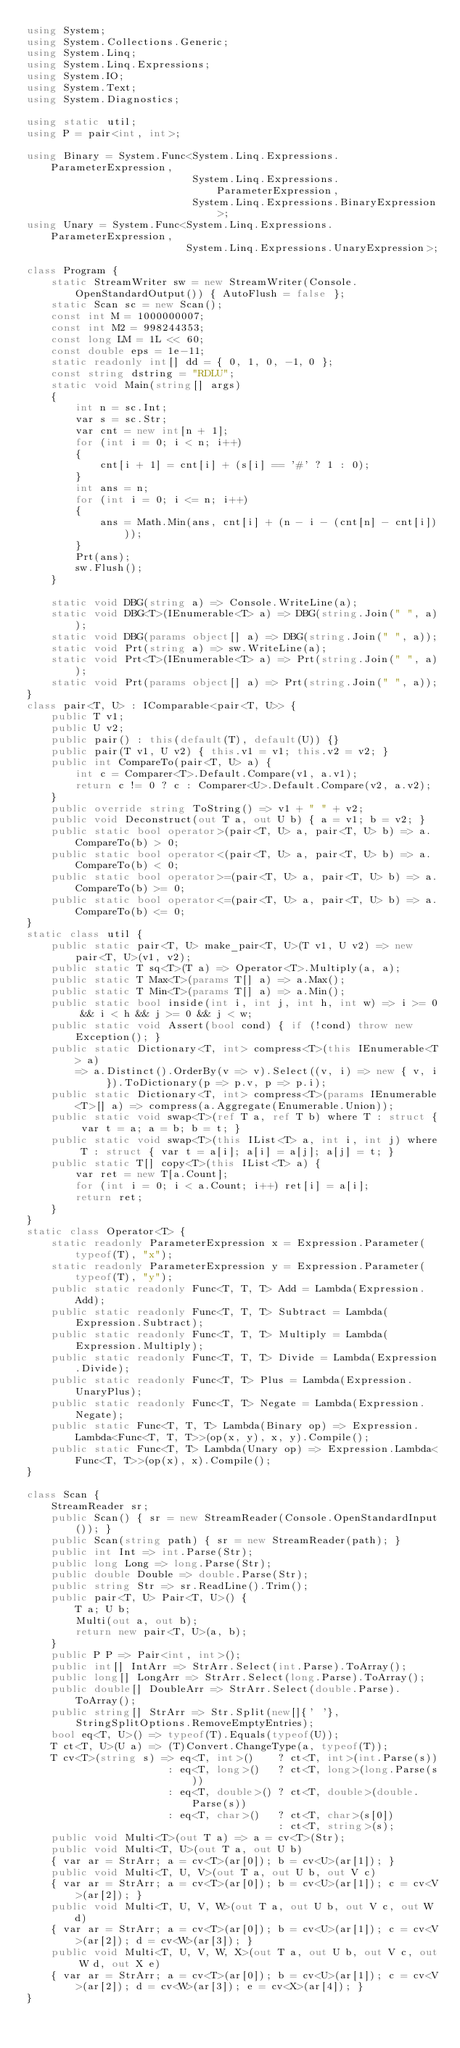<code> <loc_0><loc_0><loc_500><loc_500><_C#_>using System;
using System.Collections.Generic;
using System.Linq;
using System.Linq.Expressions;
using System.IO;
using System.Text;
using System.Diagnostics;

using static util;
using P = pair<int, int>;

using Binary = System.Func<System.Linq.Expressions.ParameterExpression,
                           System.Linq.Expressions.ParameterExpression,
                           System.Linq.Expressions.BinaryExpression>;
using Unary = System.Func<System.Linq.Expressions.ParameterExpression,
                          System.Linq.Expressions.UnaryExpression>;

class Program {
    static StreamWriter sw = new StreamWriter(Console.OpenStandardOutput()) { AutoFlush = false };
    static Scan sc = new Scan();
    const int M = 1000000007;
    const int M2 = 998244353;
    const long LM = 1L << 60;
    const double eps = 1e-11;
    static readonly int[] dd = { 0, 1, 0, -1, 0 };
    const string dstring = "RDLU";
    static void Main(string[] args)
    {
        int n = sc.Int;
        var s = sc.Str;
        var cnt = new int[n + 1];
        for (int i = 0; i < n; i++)
        {
            cnt[i + 1] = cnt[i] + (s[i] == '#' ? 1 : 0);
        }
        int ans = n;
        for (int i = 0; i <= n; i++)
        {
            ans = Math.Min(ans, cnt[i] + (n - i - (cnt[n] - cnt[i])));
        }
        Prt(ans);
        sw.Flush();
    }

    static void DBG(string a) => Console.WriteLine(a);
    static void DBG<T>(IEnumerable<T> a) => DBG(string.Join(" ", a));
    static void DBG(params object[] a) => DBG(string.Join(" ", a));
    static void Prt(string a) => sw.WriteLine(a);
    static void Prt<T>(IEnumerable<T> a) => Prt(string.Join(" ", a));
    static void Prt(params object[] a) => Prt(string.Join(" ", a));
}
class pair<T, U> : IComparable<pair<T, U>> {
    public T v1;
    public U v2;
    public pair() : this(default(T), default(U)) {}
    public pair(T v1, U v2) { this.v1 = v1; this.v2 = v2; }
    public int CompareTo(pair<T, U> a) {
        int c = Comparer<T>.Default.Compare(v1, a.v1);
        return c != 0 ? c : Comparer<U>.Default.Compare(v2, a.v2);
    }
    public override string ToString() => v1 + " " + v2;
    public void Deconstruct(out T a, out U b) { a = v1; b = v2; }
    public static bool operator>(pair<T, U> a, pair<T, U> b) => a.CompareTo(b) > 0;
    public static bool operator<(pair<T, U> a, pair<T, U> b) => a.CompareTo(b) < 0;
    public static bool operator>=(pair<T, U> a, pair<T, U> b) => a.CompareTo(b) >= 0;
    public static bool operator<=(pair<T, U> a, pair<T, U> b) => a.CompareTo(b) <= 0;
}
static class util {
    public static pair<T, U> make_pair<T, U>(T v1, U v2) => new pair<T, U>(v1, v2);
    public static T sq<T>(T a) => Operator<T>.Multiply(a, a);
    public static T Max<T>(params T[] a) => a.Max();
    public static T Min<T>(params T[] a) => a.Min();
    public static bool inside(int i, int j, int h, int w) => i >= 0 && i < h && j >= 0 && j < w;
    public static void Assert(bool cond) { if (!cond) throw new Exception(); }
    public static Dictionary<T, int> compress<T>(this IEnumerable<T> a)
        => a.Distinct().OrderBy(v => v).Select((v, i) => new { v, i }).ToDictionary(p => p.v, p => p.i);
    public static Dictionary<T, int> compress<T>(params IEnumerable<T>[] a) => compress(a.Aggregate(Enumerable.Union));
    public static void swap<T>(ref T a, ref T b) where T : struct { var t = a; a = b; b = t; }
    public static void swap<T>(this IList<T> a, int i, int j) where T : struct { var t = a[i]; a[i] = a[j]; a[j] = t; }
    public static T[] copy<T>(this IList<T> a) {
        var ret = new T[a.Count];
        for (int i = 0; i < a.Count; i++) ret[i] = a[i];
        return ret;
    }
}
static class Operator<T> {
    static readonly ParameterExpression x = Expression.Parameter(typeof(T), "x");
    static readonly ParameterExpression y = Expression.Parameter(typeof(T), "y");
    public static readonly Func<T, T, T> Add = Lambda(Expression.Add);
    public static readonly Func<T, T, T> Subtract = Lambda(Expression.Subtract);
    public static readonly Func<T, T, T> Multiply = Lambda(Expression.Multiply);
    public static readonly Func<T, T, T> Divide = Lambda(Expression.Divide);
    public static readonly Func<T, T> Plus = Lambda(Expression.UnaryPlus);
    public static readonly Func<T, T> Negate = Lambda(Expression.Negate);
    public static Func<T, T, T> Lambda(Binary op) => Expression.Lambda<Func<T, T, T>>(op(x, y), x, y).Compile();
    public static Func<T, T> Lambda(Unary op) => Expression.Lambda<Func<T, T>>(op(x), x).Compile();
}

class Scan {
    StreamReader sr;
    public Scan() { sr = new StreamReader(Console.OpenStandardInput()); }
    public Scan(string path) { sr = new StreamReader(path); }
    public int Int => int.Parse(Str);
    public long Long => long.Parse(Str);
    public double Double => double.Parse(Str);
    public string Str => sr.ReadLine().Trim();
    public pair<T, U> Pair<T, U>() {
        T a; U b;
        Multi(out a, out b);
        return new pair<T, U>(a, b);
    }
    public P P => Pair<int, int>();
    public int[] IntArr => StrArr.Select(int.Parse).ToArray();
    public long[] LongArr => StrArr.Select(long.Parse).ToArray();
    public double[] DoubleArr => StrArr.Select(double.Parse).ToArray();
    public string[] StrArr => Str.Split(new[]{' '}, StringSplitOptions.RemoveEmptyEntries);
    bool eq<T, U>() => typeof(T).Equals(typeof(U));
    T ct<T, U>(U a) => (T)Convert.ChangeType(a, typeof(T));
    T cv<T>(string s) => eq<T, int>()    ? ct<T, int>(int.Parse(s))
                       : eq<T, long>()   ? ct<T, long>(long.Parse(s))
                       : eq<T, double>() ? ct<T, double>(double.Parse(s))
                       : eq<T, char>()   ? ct<T, char>(s[0])
                                         : ct<T, string>(s);
    public void Multi<T>(out T a) => a = cv<T>(Str);
    public void Multi<T, U>(out T a, out U b)
    { var ar = StrArr; a = cv<T>(ar[0]); b = cv<U>(ar[1]); }
    public void Multi<T, U, V>(out T a, out U b, out V c)
    { var ar = StrArr; a = cv<T>(ar[0]); b = cv<U>(ar[1]); c = cv<V>(ar[2]); }
    public void Multi<T, U, V, W>(out T a, out U b, out V c, out W d)
    { var ar = StrArr; a = cv<T>(ar[0]); b = cv<U>(ar[1]); c = cv<V>(ar[2]); d = cv<W>(ar[3]); }
    public void Multi<T, U, V, W, X>(out T a, out U b, out V c, out W d, out X e)
    { var ar = StrArr; a = cv<T>(ar[0]); b = cv<U>(ar[1]); c = cv<V>(ar[2]); d = cv<W>(ar[3]); e = cv<X>(ar[4]); }
}
</code> 